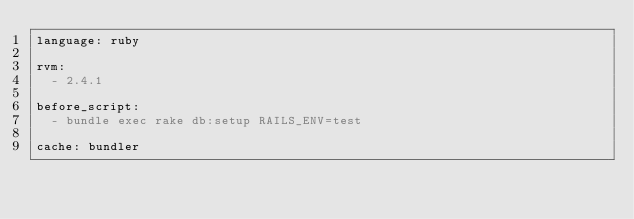<code> <loc_0><loc_0><loc_500><loc_500><_YAML_>language: ruby

rvm:
  - 2.4.1

before_script:
  - bundle exec rake db:setup RAILS_ENV=test

cache: bundler

</code> 